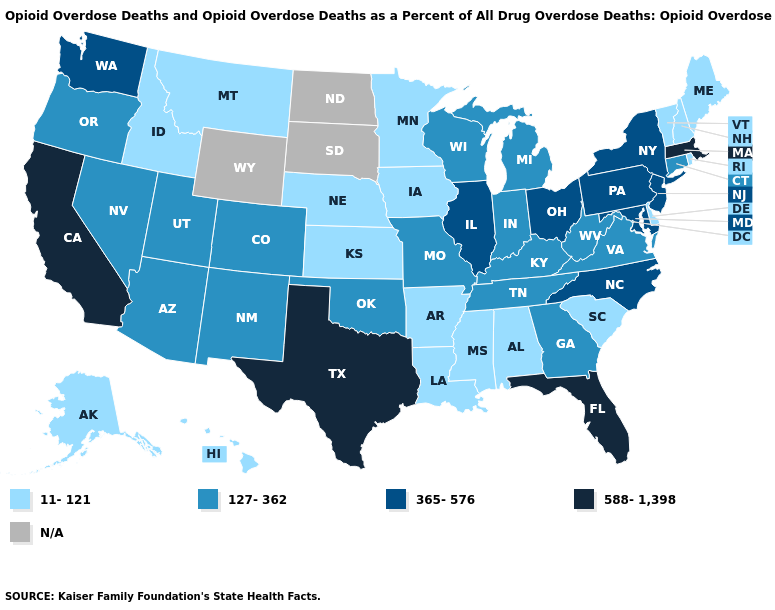Which states have the highest value in the USA?
Give a very brief answer. California, Florida, Massachusetts, Texas. What is the highest value in the USA?
Quick response, please. 588-1,398. What is the highest value in states that border North Carolina?
Answer briefly. 127-362. What is the value of Montana?
Answer briefly. 11-121. Name the states that have a value in the range 365-576?
Write a very short answer. Illinois, Maryland, New Jersey, New York, North Carolina, Ohio, Pennsylvania, Washington. Which states have the lowest value in the USA?
Write a very short answer. Alabama, Alaska, Arkansas, Delaware, Hawaii, Idaho, Iowa, Kansas, Louisiana, Maine, Minnesota, Mississippi, Montana, Nebraska, New Hampshire, Rhode Island, South Carolina, Vermont. What is the value of California?
Short answer required. 588-1,398. Does New Jersey have the lowest value in the USA?
Concise answer only. No. Which states have the lowest value in the MidWest?
Keep it brief. Iowa, Kansas, Minnesota, Nebraska. What is the value of Idaho?
Keep it brief. 11-121. Does Florida have the highest value in the South?
Short answer required. Yes. What is the value of Massachusetts?
Be succinct. 588-1,398. Which states have the lowest value in the USA?
Answer briefly. Alabama, Alaska, Arkansas, Delaware, Hawaii, Idaho, Iowa, Kansas, Louisiana, Maine, Minnesota, Mississippi, Montana, Nebraska, New Hampshire, Rhode Island, South Carolina, Vermont. Among the states that border North Carolina , which have the lowest value?
Quick response, please. South Carolina. 